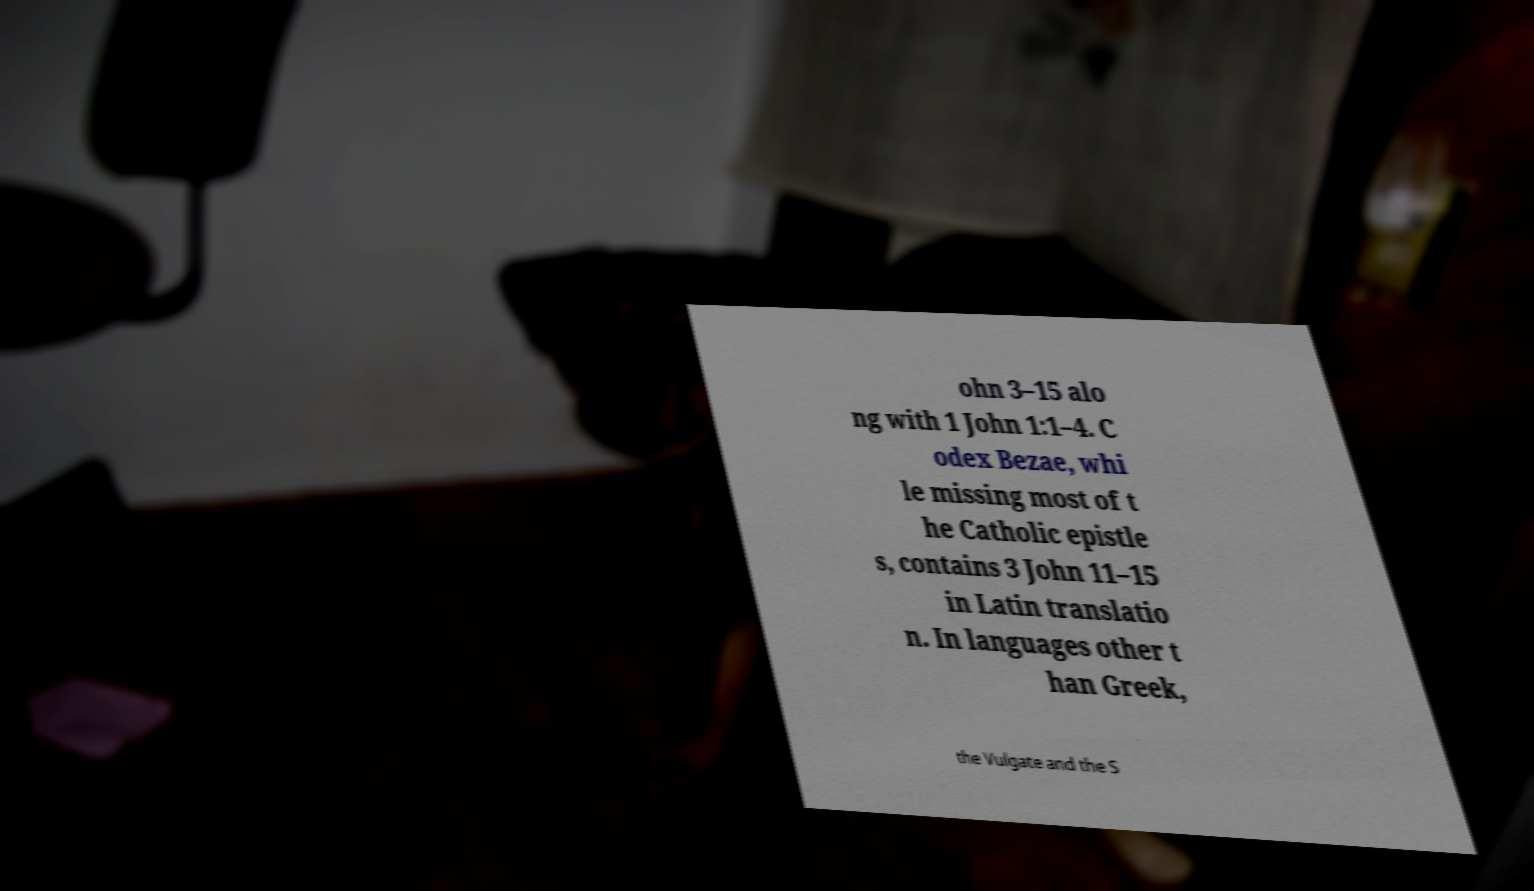What messages or text are displayed in this image? I need them in a readable, typed format. ohn 3–15 alo ng with 1 John 1:1–4. C odex Bezae, whi le missing most of t he Catholic epistle s, contains 3 John 11–15 in Latin translatio n. In languages other t han Greek, the Vulgate and the S 